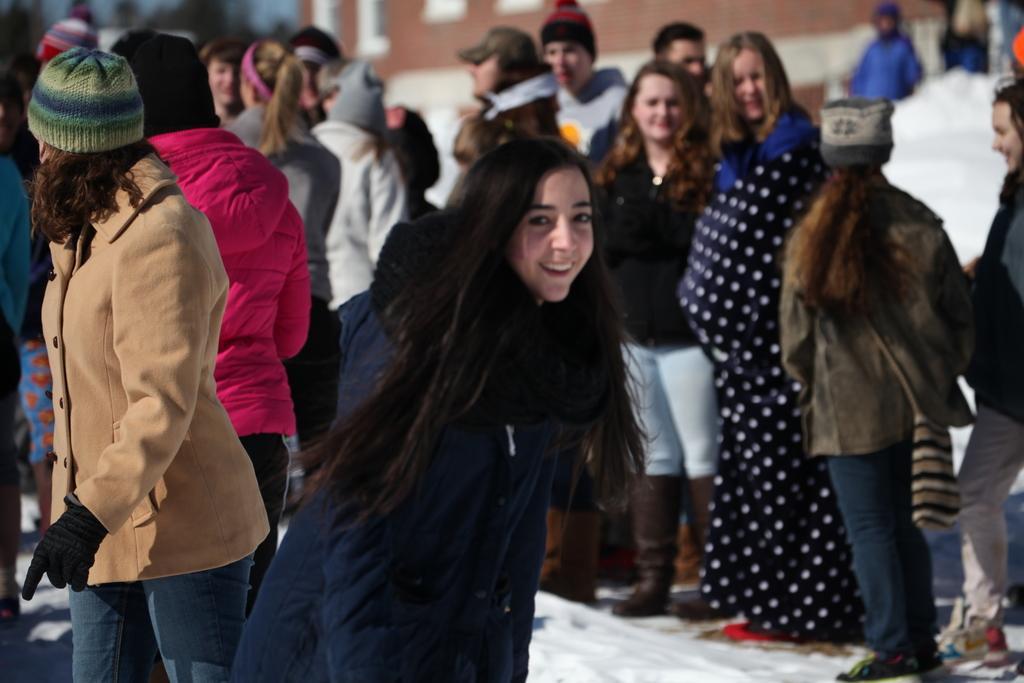Can you describe this image briefly? In this picture we can see a few people in snow. There is a building in the background. 